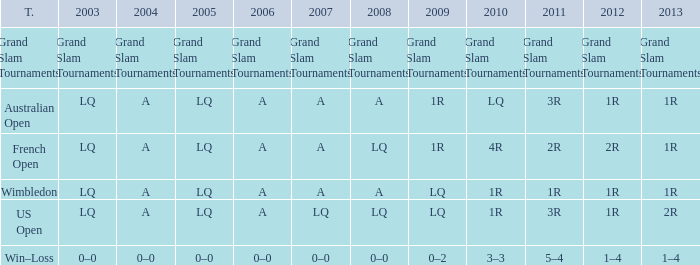Which year has a 2011 of 1r? A. 